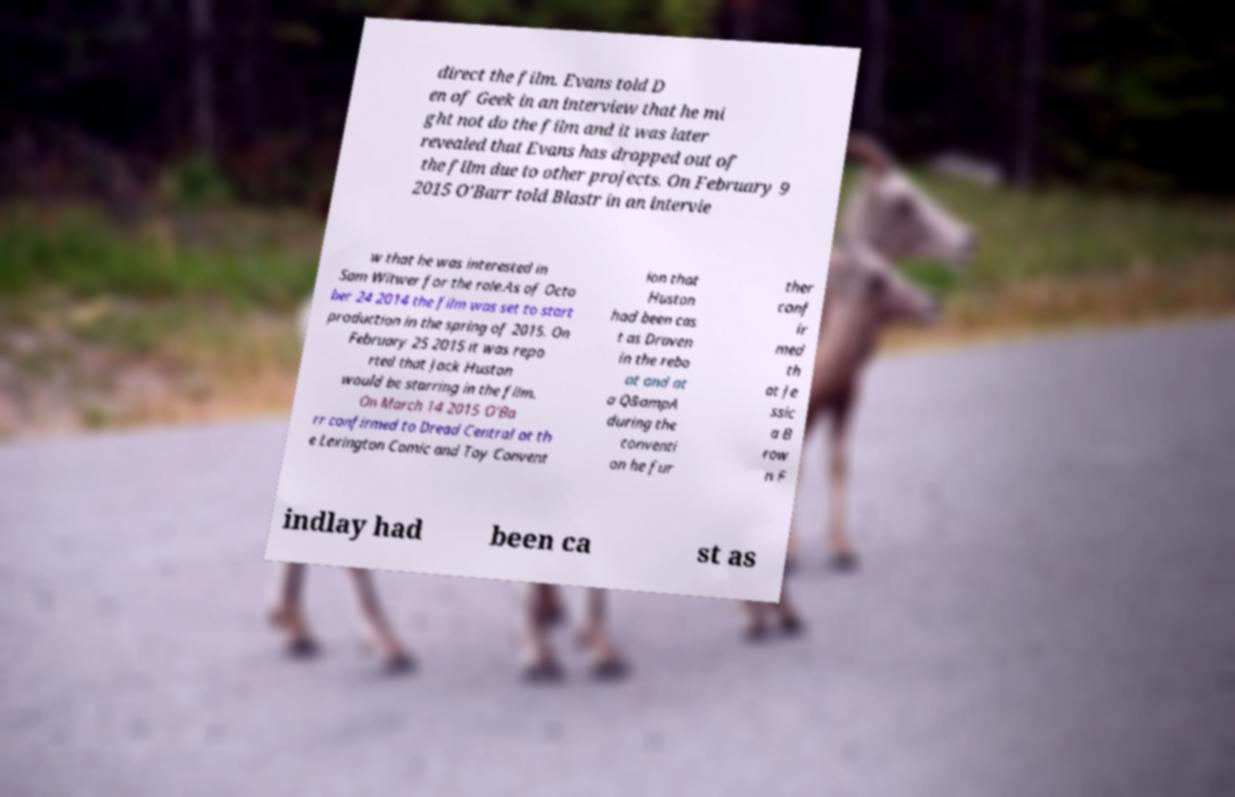Please identify and transcribe the text found in this image. direct the film. Evans told D en of Geek in an interview that he mi ght not do the film and it was later revealed that Evans has dropped out of the film due to other projects. On February 9 2015 O'Barr told Blastr in an intervie w that he was interested in Sam Witwer for the role.As of Octo ber 24 2014 the film was set to start production in the spring of 2015. On February 25 2015 it was repo rted that Jack Huston would be starring in the film. On March 14 2015 O'Ba rr confirmed to Dread Central at th e Lexington Comic and Toy Convent ion that Huston had been cas t as Draven in the rebo ot and at a Q&ampA during the conventi on he fur ther conf ir med th at Je ssic a B row n F indlay had been ca st as 